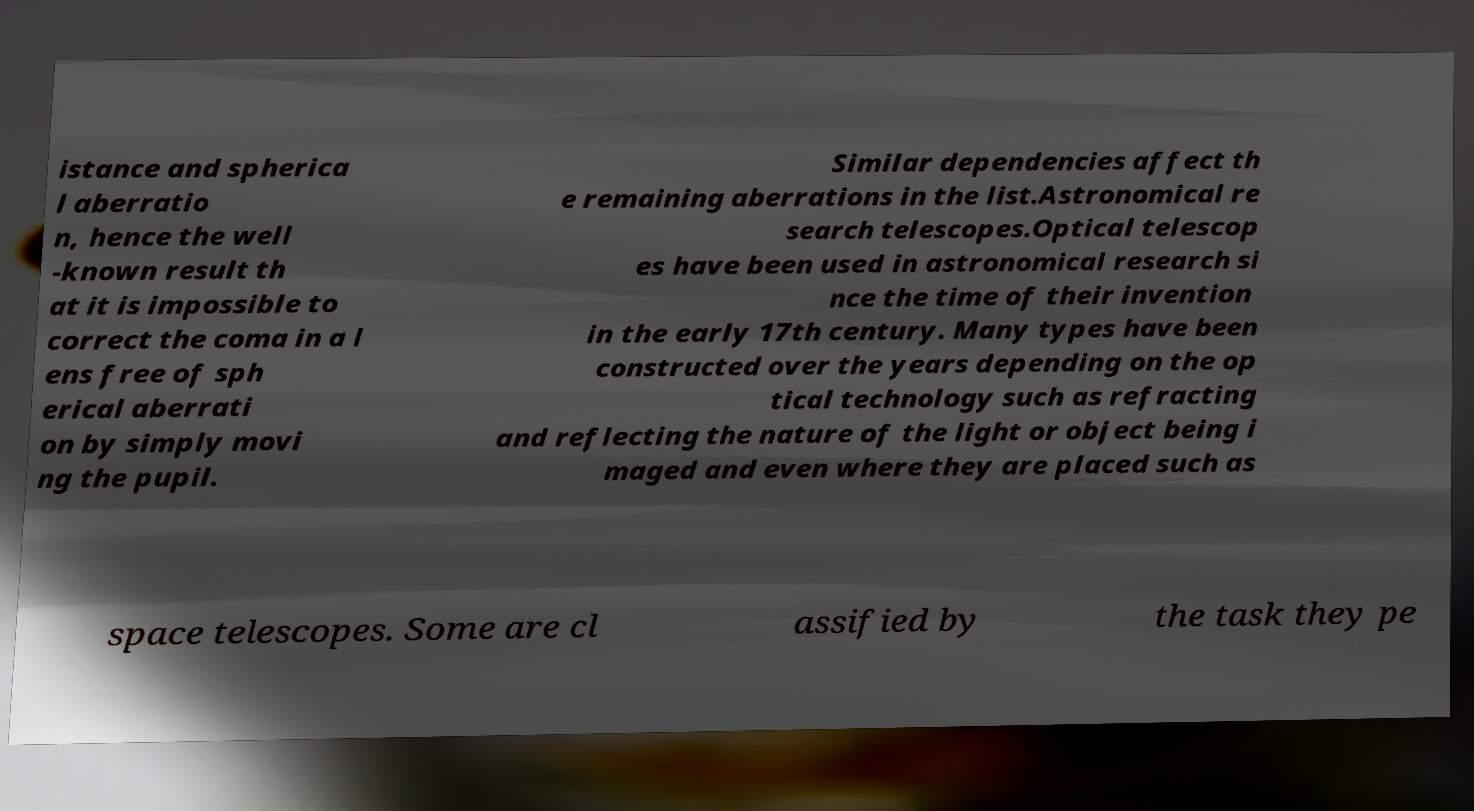Please identify and transcribe the text found in this image. istance and spherica l aberratio n, hence the well -known result th at it is impossible to correct the coma in a l ens free of sph erical aberrati on by simply movi ng the pupil. Similar dependencies affect th e remaining aberrations in the list.Astronomical re search telescopes.Optical telescop es have been used in astronomical research si nce the time of their invention in the early 17th century. Many types have been constructed over the years depending on the op tical technology such as refracting and reflecting the nature of the light or object being i maged and even where they are placed such as space telescopes. Some are cl assified by the task they pe 